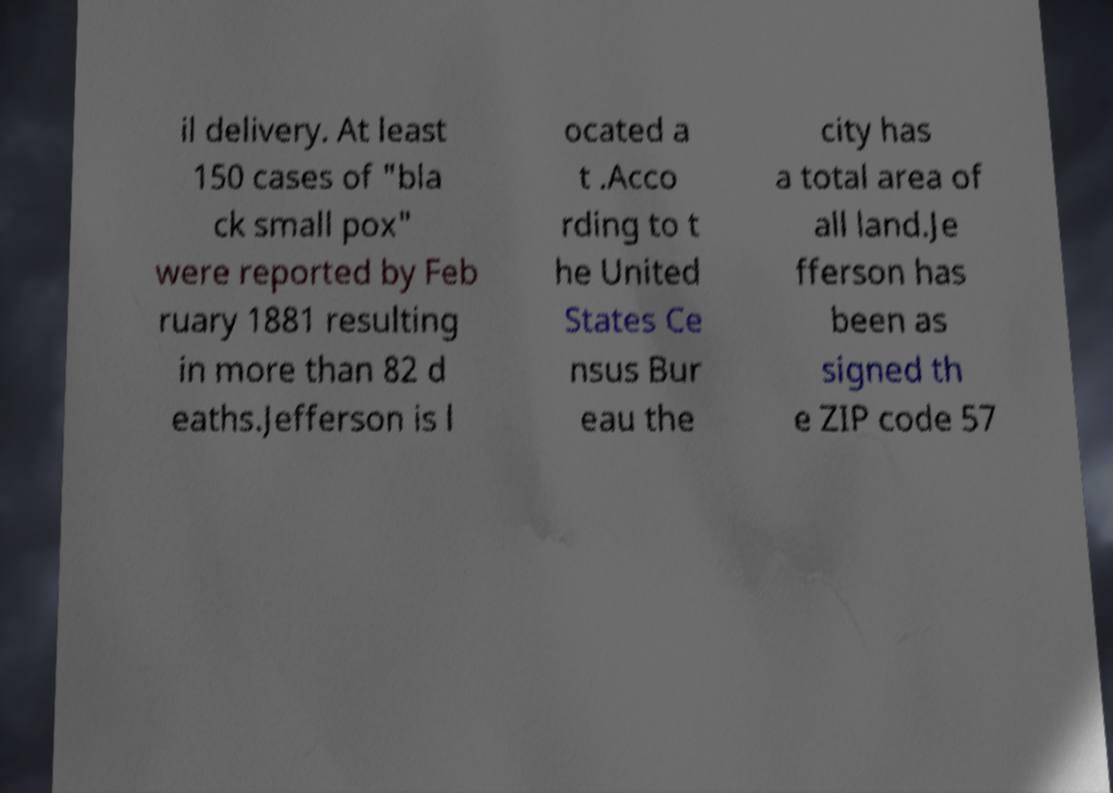What messages or text are displayed in this image? I need them in a readable, typed format. il delivery. At least 150 cases of "bla ck small pox" were reported by Feb ruary 1881 resulting in more than 82 d eaths.Jefferson is l ocated a t .Acco rding to t he United States Ce nsus Bur eau the city has a total area of all land.Je fferson has been as signed th e ZIP code 57 